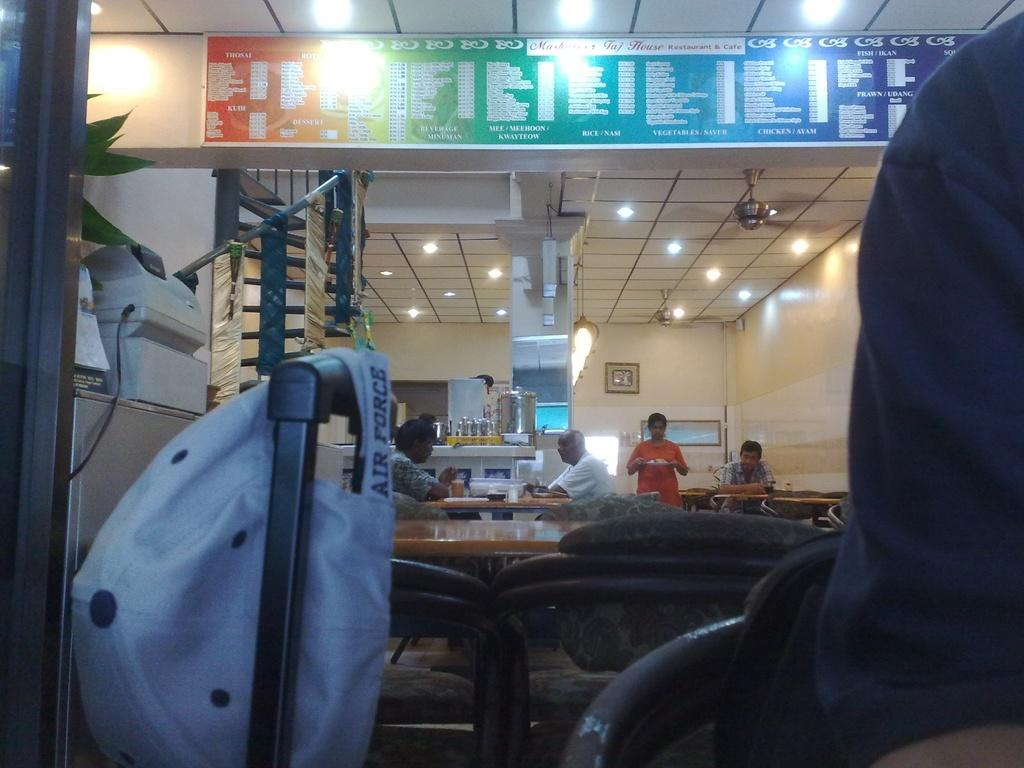What object can be seen in the image that is typically worn on the head? There is a cap in the image. What are the people in the image doing? The people are sitting at a table in the image. What can be seen in the image that provides illumination? There are lights in the image. What device is present in the image that circulates air? There is a fan in the image. What objects are on the table in the image? There are containers on the table in the image. What word is being spoken by the people sitting at the table in the image? There is no information about any words being spoken in the image. What type of engine can be seen powering the fan in the image? There is no engine present in the image; it is a fan that circulates air. 